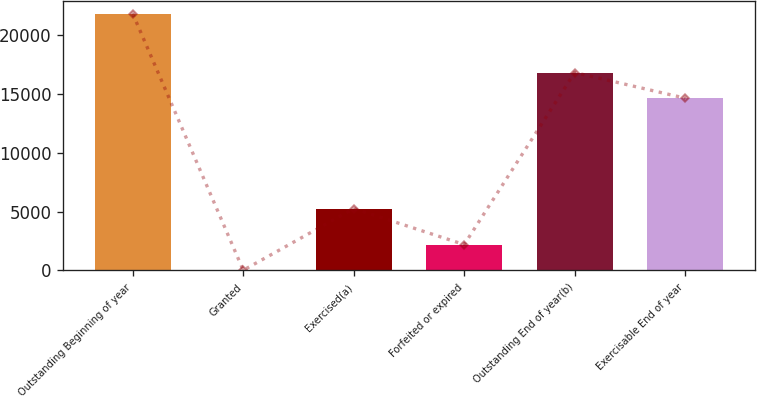<chart> <loc_0><loc_0><loc_500><loc_500><bar_chart><fcel>Outstanding Beginning of year<fcel>Granted<fcel>Exercised(a)<fcel>Forfeited or expired<fcel>Outstanding End of year(b)<fcel>Exercisable End of year<nl><fcel>21779<fcel>17<fcel>5252<fcel>2193.2<fcel>16794.2<fcel>14618<nl></chart> 